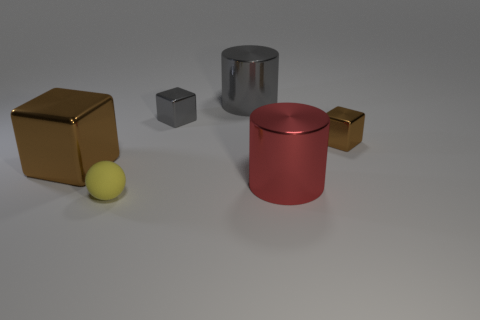There is another metallic cube that is the same color as the large cube; what is its size?
Ensure brevity in your answer.  Small. How many things are either large yellow metallic balls or big metallic cylinders behind the big red object?
Your answer should be very brief. 1. Is there a thing of the same color as the large block?
Your response must be concise. Yes. How many yellow objects are either spheres or big things?
Give a very brief answer. 1. What number of other things are the same size as the gray metallic cylinder?
Ensure brevity in your answer.  2. What number of large objects are either metal things or yellow matte spheres?
Your answer should be compact. 3. Does the rubber thing have the same size as the brown shiny block left of the large red metallic cylinder?
Give a very brief answer. No. How many other things are there of the same shape as the small brown shiny thing?
Offer a very short reply. 2. There is a big brown object that is made of the same material as the large gray object; what is its shape?
Make the answer very short. Cube. Is there a large shiny cylinder?
Provide a succinct answer. Yes. 